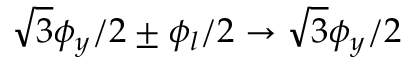Convert formula to latex. <formula><loc_0><loc_0><loc_500><loc_500>\sqrt { 3 } \phi _ { y } / 2 \pm \phi _ { l } / 2 \rightarrow \sqrt { 3 } \phi _ { y } / 2</formula> 